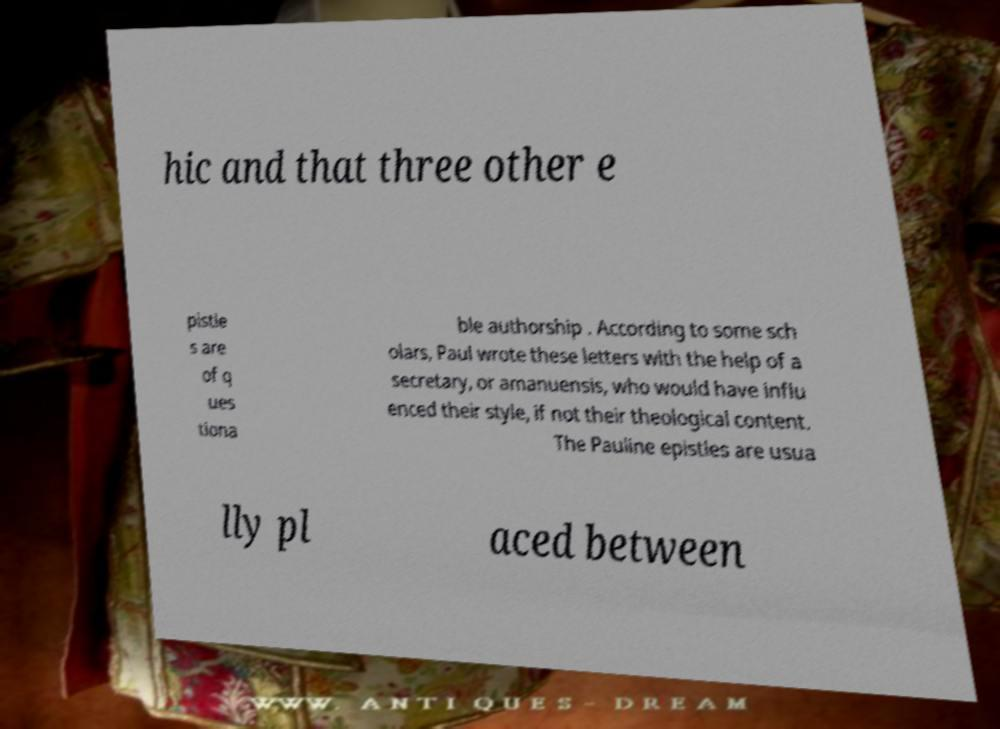Can you accurately transcribe the text from the provided image for me? hic and that three other e pistle s are of q ues tiona ble authorship . According to some sch olars, Paul wrote these letters with the help of a secretary, or amanuensis, who would have influ enced their style, if not their theological content. The Pauline epistles are usua lly pl aced between 